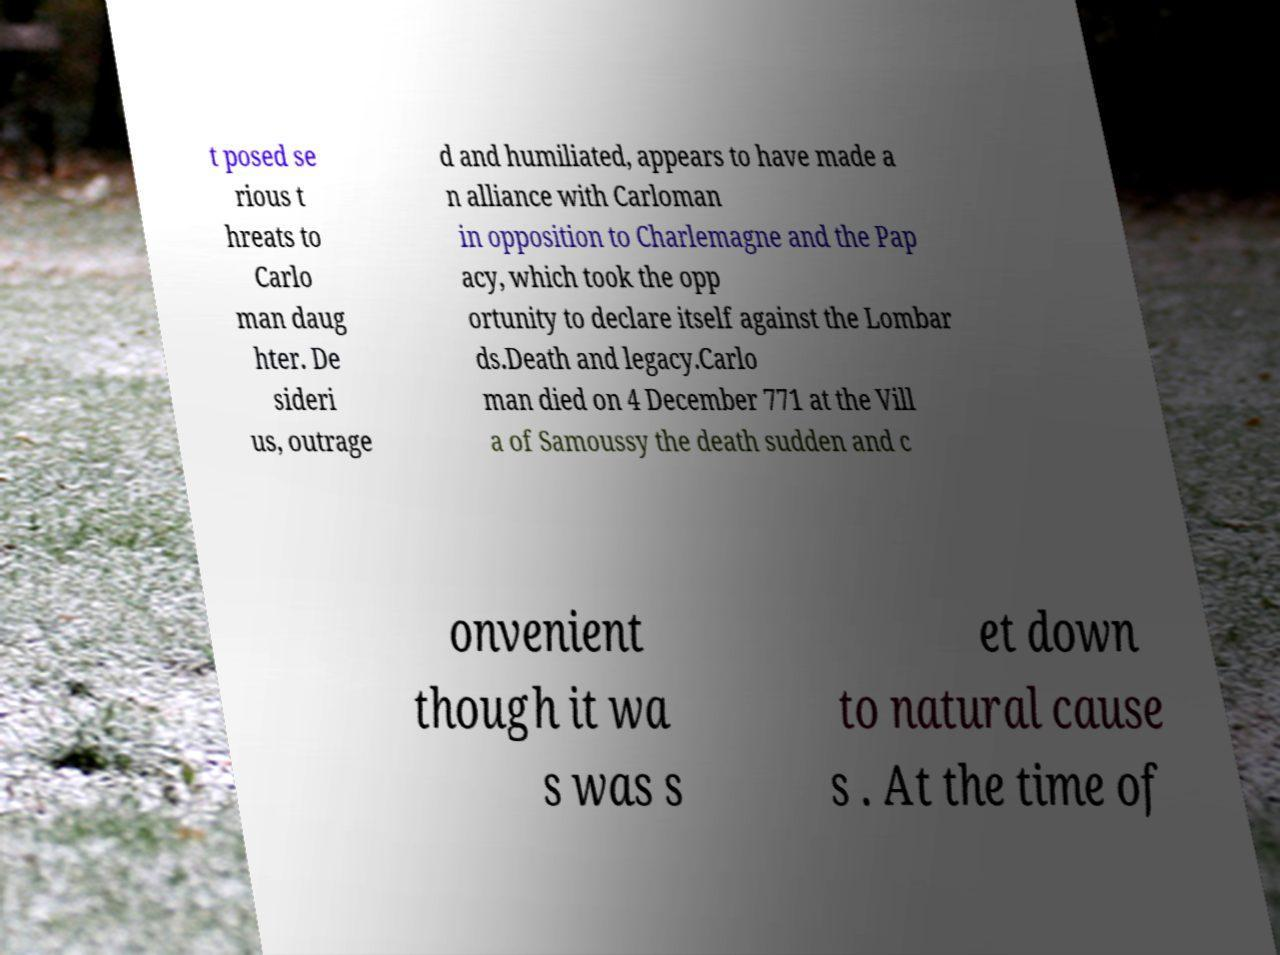Could you assist in decoding the text presented in this image and type it out clearly? t posed se rious t hreats to Carlo man daug hter. De sideri us, outrage d and humiliated, appears to have made a n alliance with Carloman in opposition to Charlemagne and the Pap acy, which took the opp ortunity to declare itself against the Lombar ds.Death and legacy.Carlo man died on 4 December 771 at the Vill a of Samoussy the death sudden and c onvenient though it wa s was s et down to natural cause s . At the time of 